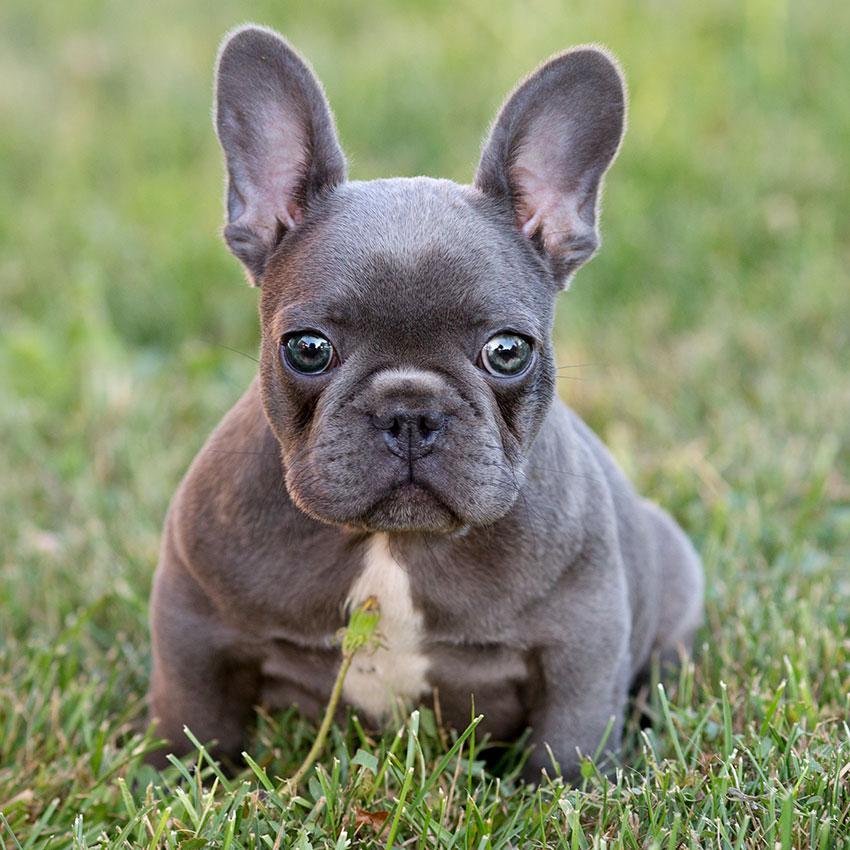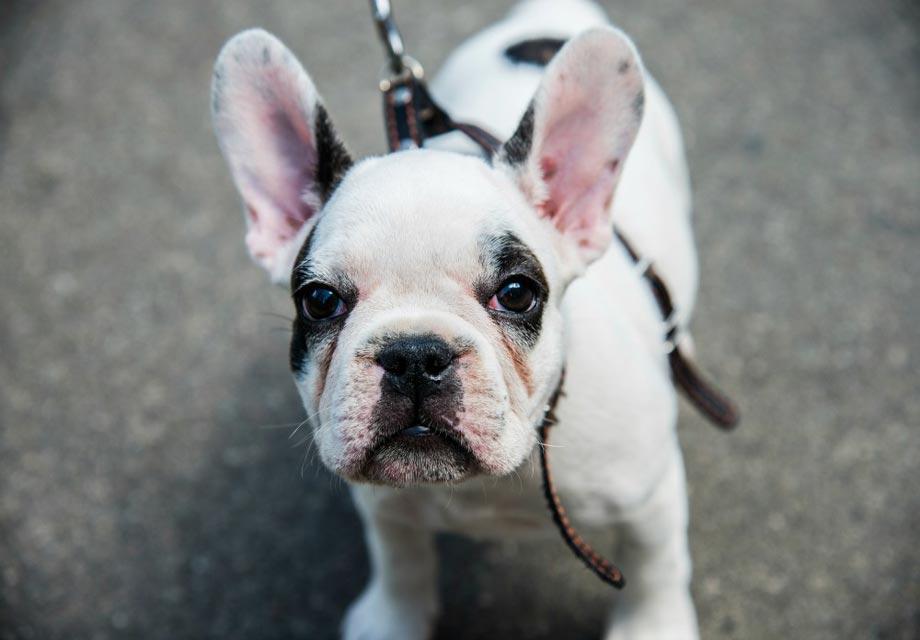The first image is the image on the left, the second image is the image on the right. For the images displayed, is the sentence "At least one image features a puppy on the grass." factually correct? Answer yes or no. Yes. 